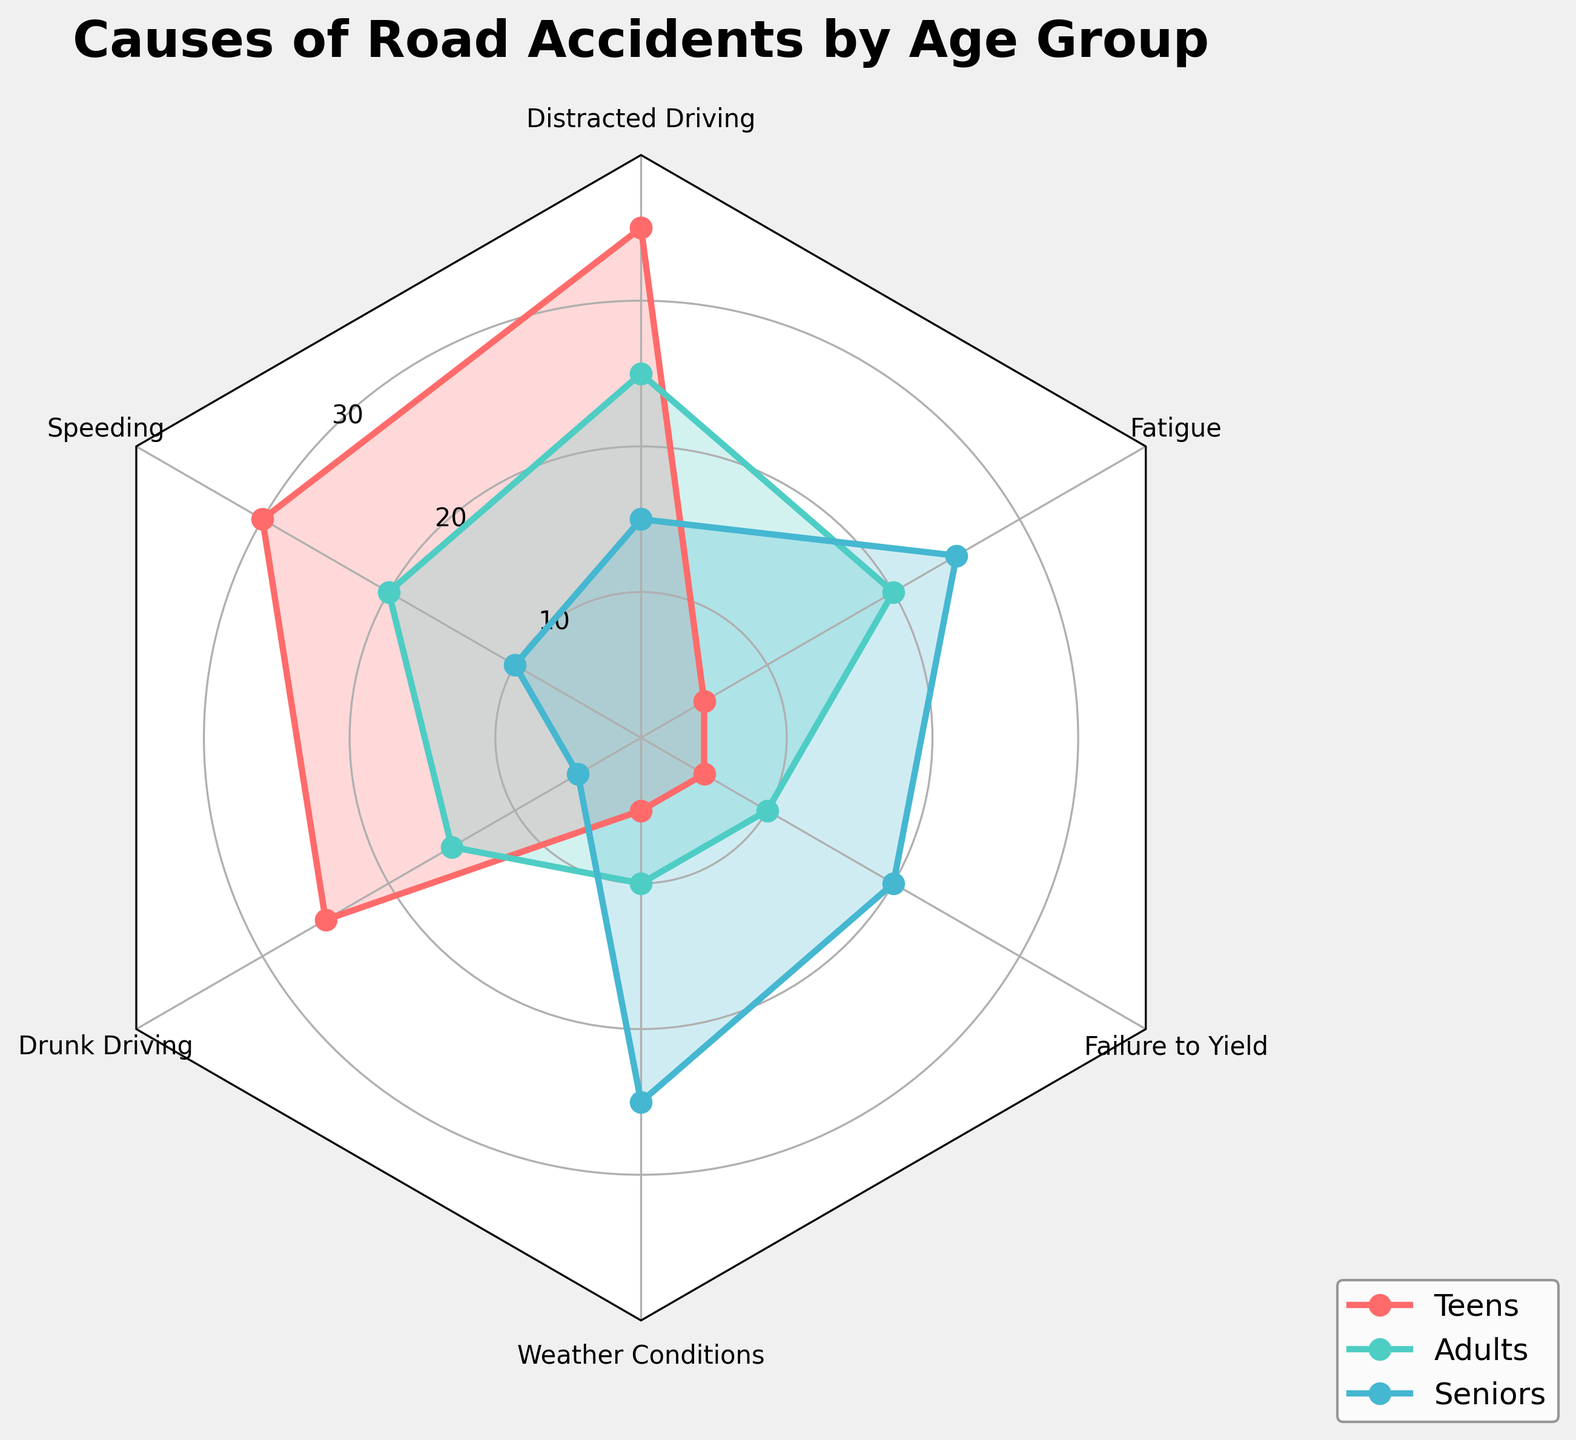What is the title of the chart? The title is located at the top of the chart and is bold and larger than the other text. The chart title reads "Causes of Road Accidents by Age Group".
Answer: Causes of Road Accidents by Age Group What are the age groups shown in the chart? The chart contains lines and labels for each age group. The age groups are identified by the legend to the right of the chart and are Teens, Adults, and Seniors.
Answer: Teens, Adults, Seniors Which cause of road accidents has the highest percentage for teens? By looking at the peaks of each colored line for Teens (red), we see that Distracted Driving has the highest point, marked at 35%.
Answer: Distracted Driving What is the percentage of Drunk Driving for Seniors? By locating the point labeled Drunk Driving on the chart and following the line associated with Seniors (light blue), we can see that it is marked at 5%.
Answer: 5% Compare the percentages of Fatigue for Teens and Seniors. Which is higher and by how much? Fatigue for Teens is at 5%, while for Seniors it is at 25%. To find the difference, subtract 5 from 25, resulting in 20%.
Answer: Seniors, by 20% What is the average percentage of Speeding for all age groups? For Speeding, the percentages for Teens, Adults, and Seniors are 30%, 20%, and 10% respectively. Adding these gives 60, and dividing by 3 gives an average of 20%.
Answer: 20% Which age group has the lowest incidence of Distracted Driving? By looking at the points for Distracted Driving, the Seniors group (light blue line) has the lowest at 15%.
Answer: Seniors Is the percentage of Fatigue higher for Adults or Teens? Comparing the points of Fatigue on the chart, the line for Adults (green) is marked at 20%, while for Teens (red) it is at 5%. Adults have a higher percentage.
Answer: Adults Between Speeding and Weather Conditions, which cause has a higher incidence for Adults? For Adults, the Speeding point (green line) is at 20%, and Weather Conditions is at 10%. Thus, Speeding is higher for Adults.
Answer: Speeding 